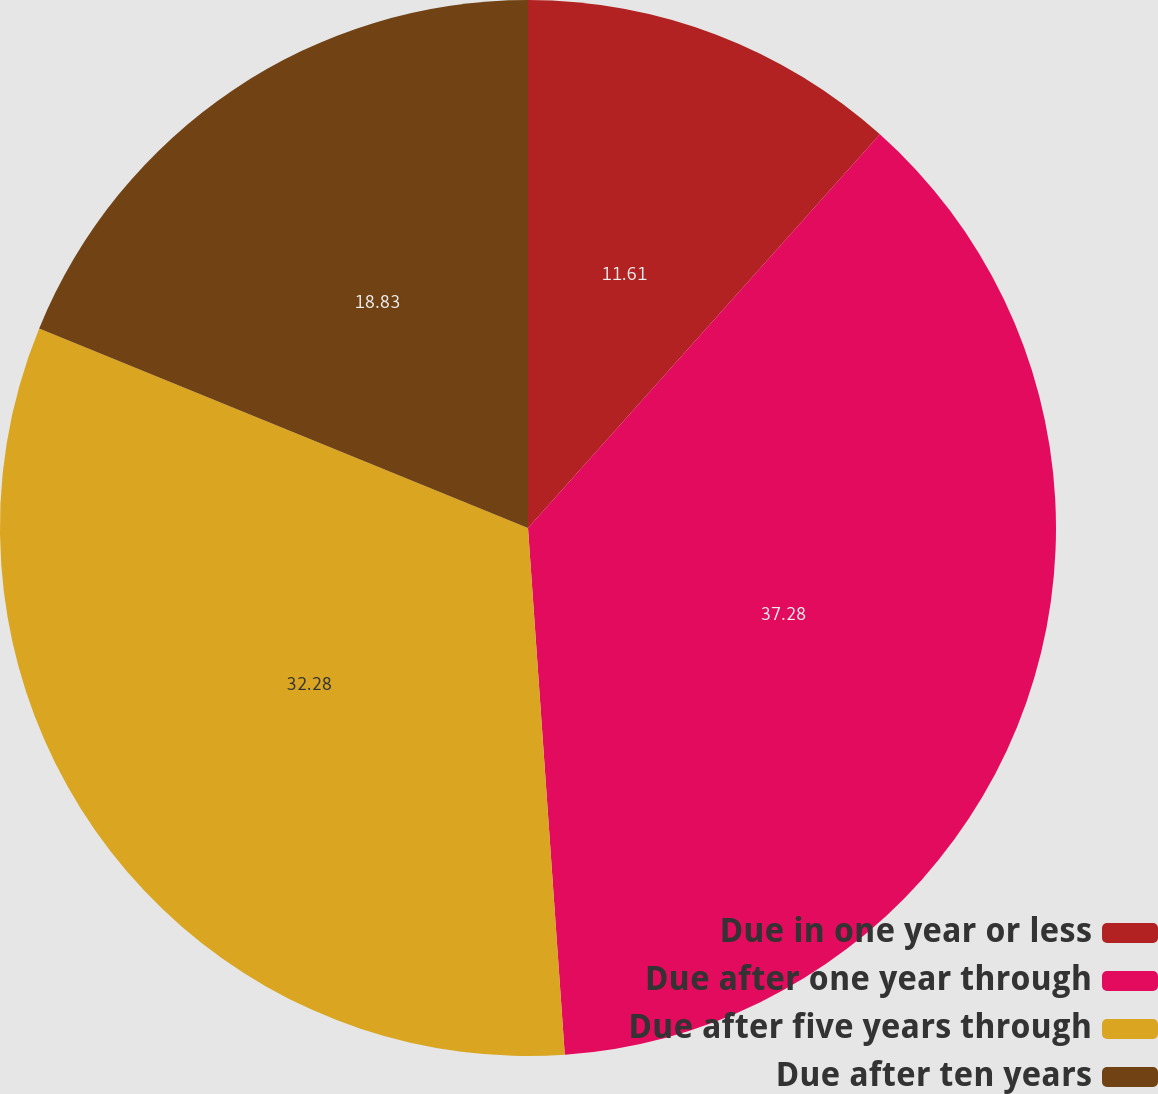<chart> <loc_0><loc_0><loc_500><loc_500><pie_chart><fcel>Due in one year or less<fcel>Due after one year through<fcel>Due after five years through<fcel>Due after ten years<nl><fcel>11.61%<fcel>37.28%<fcel>32.28%<fcel>18.83%<nl></chart> 